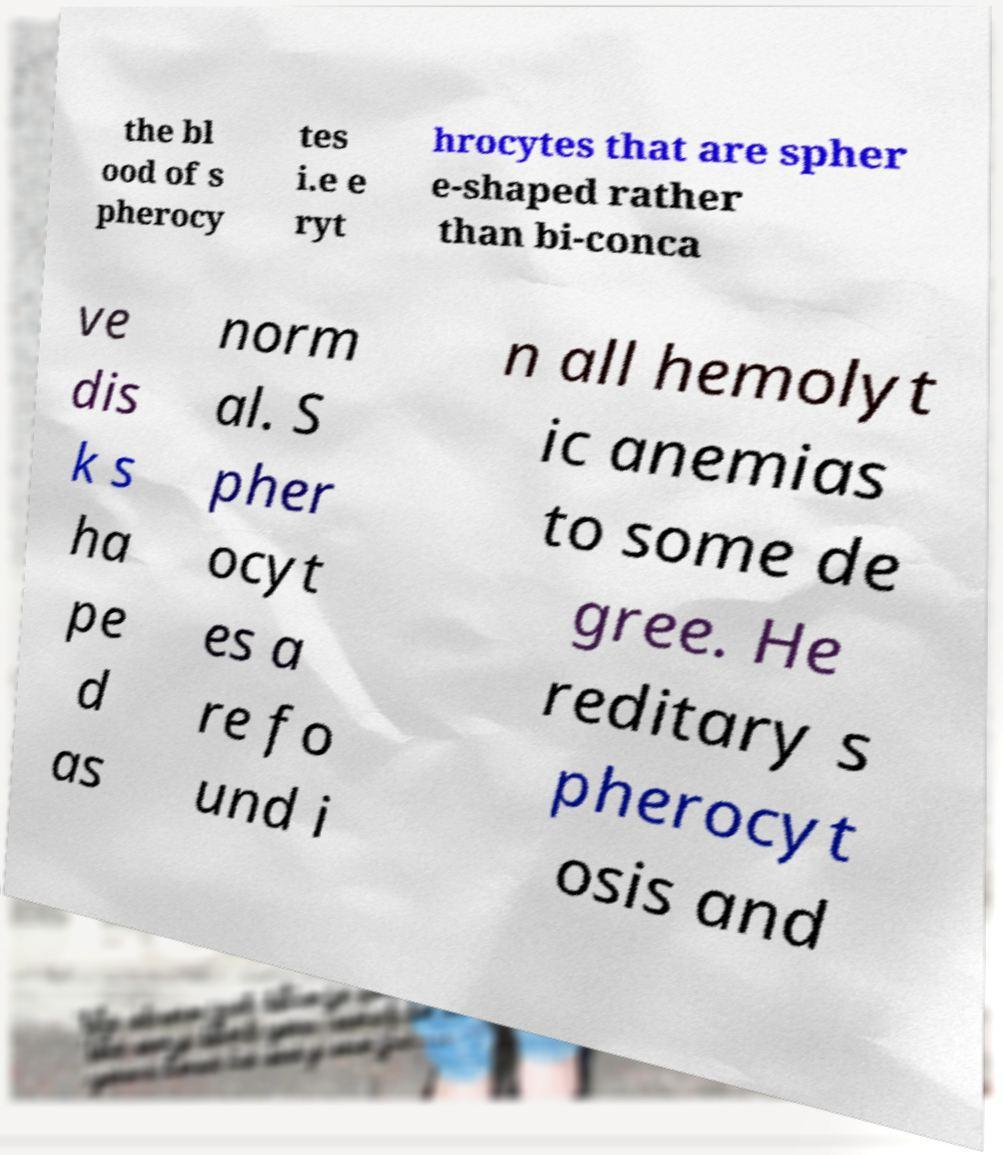Could you assist in decoding the text presented in this image and type it out clearly? the bl ood of s pherocy tes i.e e ryt hrocytes that are spher e-shaped rather than bi-conca ve dis k s ha pe d as norm al. S pher ocyt es a re fo und i n all hemolyt ic anemias to some de gree. He reditary s pherocyt osis and 